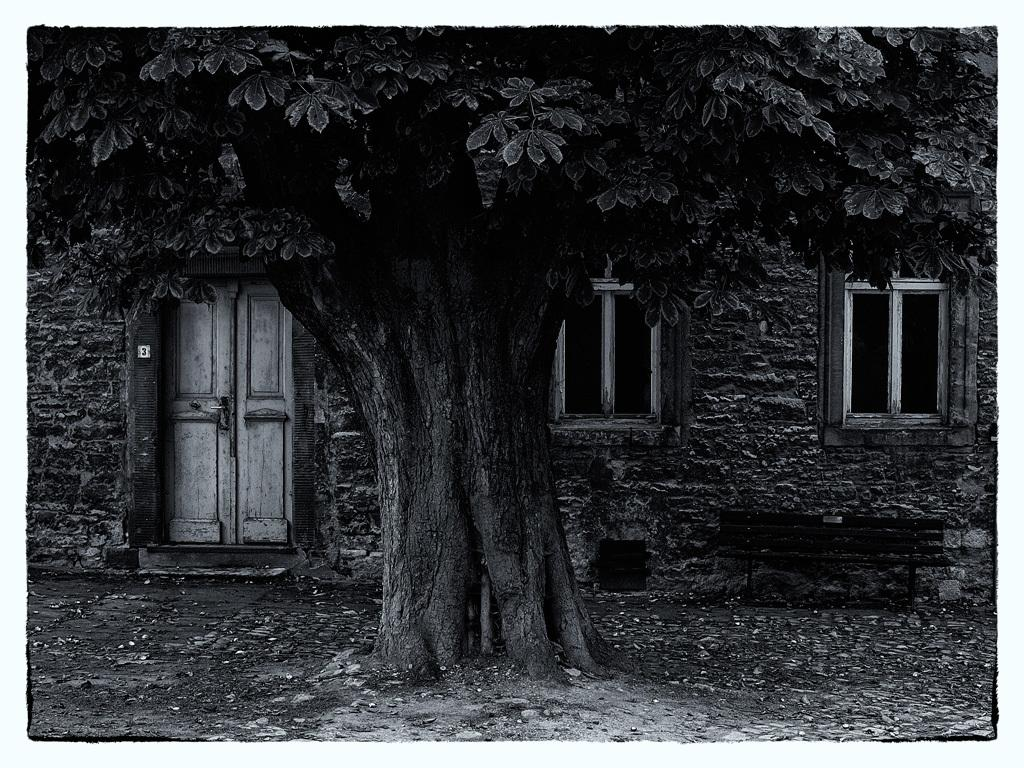What is the color scheme of the image? The image is black and white. What type of structure can be seen in the image? There is a house in the image. What features does the house have? The house has windows and a door. What can be found on the ground in the image? There are stones on the ground in the image. What objects are present in the image besides the house? There is a container, a bench, and a tree in the image. Can you see any clouds in the image? There are no clouds visible in the image, as it is black and white and does not depict a sky. Is there a toothbrush on the bench in the image? There is no toothbrush present in the image; it only features a house, stones, a container, a bench, and a tree. 